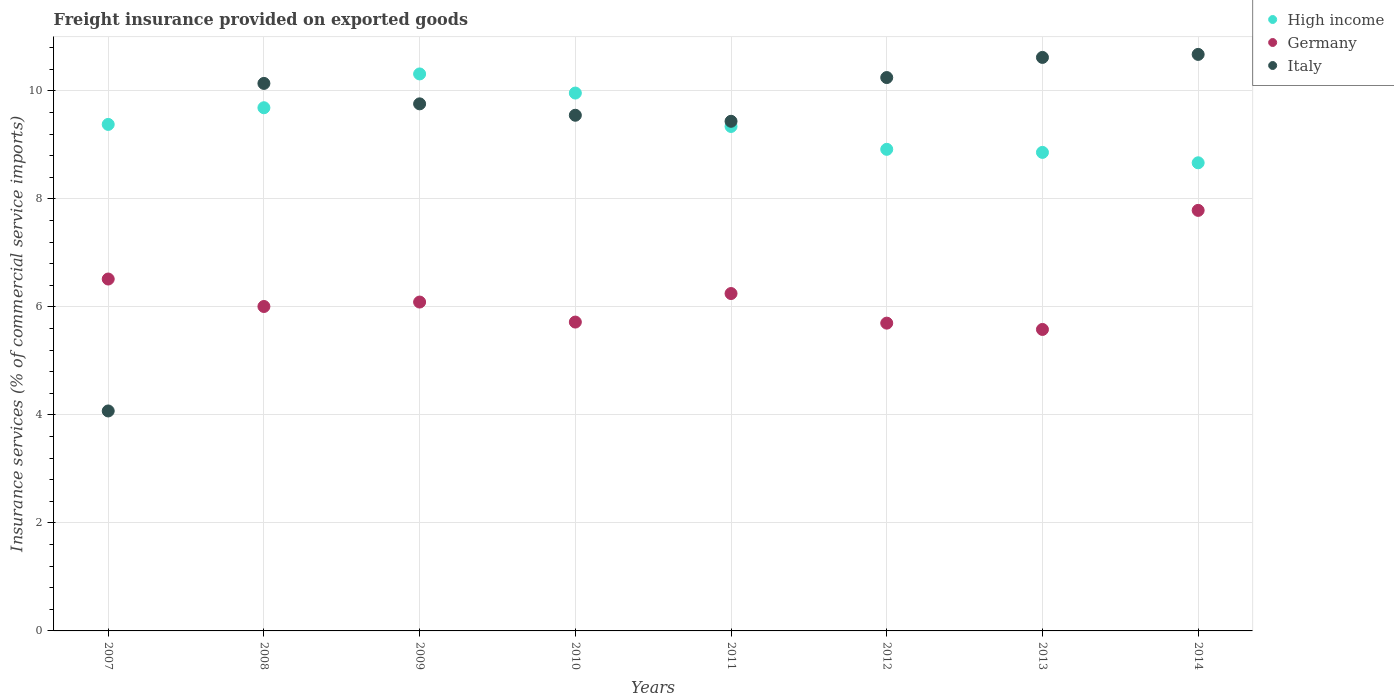How many different coloured dotlines are there?
Your answer should be compact. 3. What is the freight insurance provided on exported goods in Italy in 2007?
Ensure brevity in your answer.  4.07. Across all years, what is the maximum freight insurance provided on exported goods in Germany?
Ensure brevity in your answer.  7.79. Across all years, what is the minimum freight insurance provided on exported goods in Germany?
Your response must be concise. 5.58. What is the total freight insurance provided on exported goods in Germany in the graph?
Make the answer very short. 49.65. What is the difference between the freight insurance provided on exported goods in Italy in 2011 and that in 2014?
Ensure brevity in your answer.  -1.24. What is the difference between the freight insurance provided on exported goods in Italy in 2014 and the freight insurance provided on exported goods in Germany in 2008?
Ensure brevity in your answer.  4.67. What is the average freight insurance provided on exported goods in Italy per year?
Make the answer very short. 9.31. In the year 2007, what is the difference between the freight insurance provided on exported goods in Germany and freight insurance provided on exported goods in High income?
Offer a very short reply. -2.86. What is the ratio of the freight insurance provided on exported goods in Italy in 2011 to that in 2014?
Your response must be concise. 0.88. Is the freight insurance provided on exported goods in Germany in 2007 less than that in 2012?
Ensure brevity in your answer.  No. What is the difference between the highest and the second highest freight insurance provided on exported goods in Germany?
Give a very brief answer. 1.27. What is the difference between the highest and the lowest freight insurance provided on exported goods in Germany?
Give a very brief answer. 2.2. How many dotlines are there?
Make the answer very short. 3. How many years are there in the graph?
Keep it short and to the point. 8. What is the difference between two consecutive major ticks on the Y-axis?
Provide a short and direct response. 2. Are the values on the major ticks of Y-axis written in scientific E-notation?
Ensure brevity in your answer.  No. Does the graph contain any zero values?
Provide a short and direct response. No. What is the title of the graph?
Offer a very short reply. Freight insurance provided on exported goods. What is the label or title of the X-axis?
Your answer should be very brief. Years. What is the label or title of the Y-axis?
Give a very brief answer. Insurance services (% of commercial service imports). What is the Insurance services (% of commercial service imports) of High income in 2007?
Your response must be concise. 9.38. What is the Insurance services (% of commercial service imports) in Germany in 2007?
Provide a succinct answer. 6.52. What is the Insurance services (% of commercial service imports) in Italy in 2007?
Your answer should be compact. 4.07. What is the Insurance services (% of commercial service imports) of High income in 2008?
Ensure brevity in your answer.  9.69. What is the Insurance services (% of commercial service imports) of Germany in 2008?
Give a very brief answer. 6.01. What is the Insurance services (% of commercial service imports) of Italy in 2008?
Provide a short and direct response. 10.14. What is the Insurance services (% of commercial service imports) of High income in 2009?
Your response must be concise. 10.31. What is the Insurance services (% of commercial service imports) of Germany in 2009?
Provide a succinct answer. 6.09. What is the Insurance services (% of commercial service imports) in Italy in 2009?
Provide a short and direct response. 9.76. What is the Insurance services (% of commercial service imports) in High income in 2010?
Your response must be concise. 9.96. What is the Insurance services (% of commercial service imports) of Germany in 2010?
Provide a short and direct response. 5.72. What is the Insurance services (% of commercial service imports) in Italy in 2010?
Your answer should be compact. 9.55. What is the Insurance services (% of commercial service imports) in High income in 2011?
Offer a very short reply. 9.34. What is the Insurance services (% of commercial service imports) of Germany in 2011?
Offer a terse response. 6.25. What is the Insurance services (% of commercial service imports) in Italy in 2011?
Offer a very short reply. 9.44. What is the Insurance services (% of commercial service imports) in High income in 2012?
Offer a very short reply. 8.92. What is the Insurance services (% of commercial service imports) of Germany in 2012?
Keep it short and to the point. 5.7. What is the Insurance services (% of commercial service imports) of Italy in 2012?
Your answer should be very brief. 10.25. What is the Insurance services (% of commercial service imports) of High income in 2013?
Your answer should be very brief. 8.86. What is the Insurance services (% of commercial service imports) in Germany in 2013?
Offer a terse response. 5.58. What is the Insurance services (% of commercial service imports) in Italy in 2013?
Keep it short and to the point. 10.62. What is the Insurance services (% of commercial service imports) in High income in 2014?
Give a very brief answer. 8.67. What is the Insurance services (% of commercial service imports) of Germany in 2014?
Keep it short and to the point. 7.79. What is the Insurance services (% of commercial service imports) of Italy in 2014?
Give a very brief answer. 10.68. Across all years, what is the maximum Insurance services (% of commercial service imports) of High income?
Provide a short and direct response. 10.31. Across all years, what is the maximum Insurance services (% of commercial service imports) in Germany?
Keep it short and to the point. 7.79. Across all years, what is the maximum Insurance services (% of commercial service imports) of Italy?
Provide a short and direct response. 10.68. Across all years, what is the minimum Insurance services (% of commercial service imports) in High income?
Offer a terse response. 8.67. Across all years, what is the minimum Insurance services (% of commercial service imports) of Germany?
Make the answer very short. 5.58. Across all years, what is the minimum Insurance services (% of commercial service imports) of Italy?
Provide a short and direct response. 4.07. What is the total Insurance services (% of commercial service imports) of High income in the graph?
Provide a succinct answer. 75.13. What is the total Insurance services (% of commercial service imports) in Germany in the graph?
Your answer should be compact. 49.65. What is the total Insurance services (% of commercial service imports) in Italy in the graph?
Offer a very short reply. 74.5. What is the difference between the Insurance services (% of commercial service imports) of High income in 2007 and that in 2008?
Your answer should be compact. -0.31. What is the difference between the Insurance services (% of commercial service imports) in Germany in 2007 and that in 2008?
Your answer should be very brief. 0.51. What is the difference between the Insurance services (% of commercial service imports) in Italy in 2007 and that in 2008?
Your answer should be compact. -6.07. What is the difference between the Insurance services (% of commercial service imports) in High income in 2007 and that in 2009?
Make the answer very short. -0.93. What is the difference between the Insurance services (% of commercial service imports) of Germany in 2007 and that in 2009?
Ensure brevity in your answer.  0.43. What is the difference between the Insurance services (% of commercial service imports) of Italy in 2007 and that in 2009?
Offer a terse response. -5.69. What is the difference between the Insurance services (% of commercial service imports) in High income in 2007 and that in 2010?
Your answer should be compact. -0.58. What is the difference between the Insurance services (% of commercial service imports) in Germany in 2007 and that in 2010?
Offer a very short reply. 0.8. What is the difference between the Insurance services (% of commercial service imports) of Italy in 2007 and that in 2010?
Your answer should be compact. -5.48. What is the difference between the Insurance services (% of commercial service imports) of High income in 2007 and that in 2011?
Offer a terse response. 0.04. What is the difference between the Insurance services (% of commercial service imports) of Germany in 2007 and that in 2011?
Your response must be concise. 0.27. What is the difference between the Insurance services (% of commercial service imports) in Italy in 2007 and that in 2011?
Keep it short and to the point. -5.36. What is the difference between the Insurance services (% of commercial service imports) in High income in 2007 and that in 2012?
Offer a terse response. 0.46. What is the difference between the Insurance services (% of commercial service imports) in Germany in 2007 and that in 2012?
Give a very brief answer. 0.82. What is the difference between the Insurance services (% of commercial service imports) of Italy in 2007 and that in 2012?
Ensure brevity in your answer.  -6.17. What is the difference between the Insurance services (% of commercial service imports) of High income in 2007 and that in 2013?
Your answer should be very brief. 0.52. What is the difference between the Insurance services (% of commercial service imports) in Germany in 2007 and that in 2013?
Ensure brevity in your answer.  0.93. What is the difference between the Insurance services (% of commercial service imports) of Italy in 2007 and that in 2013?
Provide a succinct answer. -6.55. What is the difference between the Insurance services (% of commercial service imports) of High income in 2007 and that in 2014?
Ensure brevity in your answer.  0.71. What is the difference between the Insurance services (% of commercial service imports) of Germany in 2007 and that in 2014?
Give a very brief answer. -1.27. What is the difference between the Insurance services (% of commercial service imports) in Italy in 2007 and that in 2014?
Make the answer very short. -6.6. What is the difference between the Insurance services (% of commercial service imports) in High income in 2008 and that in 2009?
Offer a very short reply. -0.63. What is the difference between the Insurance services (% of commercial service imports) in Germany in 2008 and that in 2009?
Keep it short and to the point. -0.08. What is the difference between the Insurance services (% of commercial service imports) in Italy in 2008 and that in 2009?
Keep it short and to the point. 0.38. What is the difference between the Insurance services (% of commercial service imports) of High income in 2008 and that in 2010?
Ensure brevity in your answer.  -0.27. What is the difference between the Insurance services (% of commercial service imports) in Germany in 2008 and that in 2010?
Offer a very short reply. 0.29. What is the difference between the Insurance services (% of commercial service imports) in Italy in 2008 and that in 2010?
Your response must be concise. 0.59. What is the difference between the Insurance services (% of commercial service imports) in High income in 2008 and that in 2011?
Keep it short and to the point. 0.35. What is the difference between the Insurance services (% of commercial service imports) in Germany in 2008 and that in 2011?
Make the answer very short. -0.24. What is the difference between the Insurance services (% of commercial service imports) in Italy in 2008 and that in 2011?
Provide a short and direct response. 0.7. What is the difference between the Insurance services (% of commercial service imports) in High income in 2008 and that in 2012?
Your answer should be compact. 0.77. What is the difference between the Insurance services (% of commercial service imports) of Germany in 2008 and that in 2012?
Ensure brevity in your answer.  0.31. What is the difference between the Insurance services (% of commercial service imports) in Italy in 2008 and that in 2012?
Your response must be concise. -0.11. What is the difference between the Insurance services (% of commercial service imports) of High income in 2008 and that in 2013?
Provide a succinct answer. 0.83. What is the difference between the Insurance services (% of commercial service imports) of Germany in 2008 and that in 2013?
Your response must be concise. 0.43. What is the difference between the Insurance services (% of commercial service imports) in Italy in 2008 and that in 2013?
Give a very brief answer. -0.48. What is the difference between the Insurance services (% of commercial service imports) in High income in 2008 and that in 2014?
Ensure brevity in your answer.  1.02. What is the difference between the Insurance services (% of commercial service imports) in Germany in 2008 and that in 2014?
Offer a terse response. -1.78. What is the difference between the Insurance services (% of commercial service imports) of Italy in 2008 and that in 2014?
Offer a very short reply. -0.54. What is the difference between the Insurance services (% of commercial service imports) of High income in 2009 and that in 2010?
Offer a terse response. 0.35. What is the difference between the Insurance services (% of commercial service imports) of Germany in 2009 and that in 2010?
Your response must be concise. 0.37. What is the difference between the Insurance services (% of commercial service imports) of Italy in 2009 and that in 2010?
Make the answer very short. 0.21. What is the difference between the Insurance services (% of commercial service imports) of High income in 2009 and that in 2011?
Give a very brief answer. 0.97. What is the difference between the Insurance services (% of commercial service imports) of Germany in 2009 and that in 2011?
Offer a terse response. -0.16. What is the difference between the Insurance services (% of commercial service imports) of Italy in 2009 and that in 2011?
Your answer should be very brief. 0.32. What is the difference between the Insurance services (% of commercial service imports) of High income in 2009 and that in 2012?
Offer a very short reply. 1.4. What is the difference between the Insurance services (% of commercial service imports) of Germany in 2009 and that in 2012?
Your response must be concise. 0.39. What is the difference between the Insurance services (% of commercial service imports) in Italy in 2009 and that in 2012?
Provide a succinct answer. -0.49. What is the difference between the Insurance services (% of commercial service imports) of High income in 2009 and that in 2013?
Keep it short and to the point. 1.45. What is the difference between the Insurance services (% of commercial service imports) in Germany in 2009 and that in 2013?
Your answer should be compact. 0.51. What is the difference between the Insurance services (% of commercial service imports) of Italy in 2009 and that in 2013?
Offer a terse response. -0.86. What is the difference between the Insurance services (% of commercial service imports) in High income in 2009 and that in 2014?
Your answer should be compact. 1.65. What is the difference between the Insurance services (% of commercial service imports) of Germany in 2009 and that in 2014?
Keep it short and to the point. -1.7. What is the difference between the Insurance services (% of commercial service imports) in Italy in 2009 and that in 2014?
Offer a terse response. -0.92. What is the difference between the Insurance services (% of commercial service imports) in High income in 2010 and that in 2011?
Keep it short and to the point. 0.62. What is the difference between the Insurance services (% of commercial service imports) of Germany in 2010 and that in 2011?
Ensure brevity in your answer.  -0.53. What is the difference between the Insurance services (% of commercial service imports) in Italy in 2010 and that in 2011?
Ensure brevity in your answer.  0.11. What is the difference between the Insurance services (% of commercial service imports) of High income in 2010 and that in 2012?
Offer a terse response. 1.04. What is the difference between the Insurance services (% of commercial service imports) of Germany in 2010 and that in 2012?
Make the answer very short. 0.02. What is the difference between the Insurance services (% of commercial service imports) of Italy in 2010 and that in 2012?
Offer a terse response. -0.7. What is the difference between the Insurance services (% of commercial service imports) of High income in 2010 and that in 2013?
Keep it short and to the point. 1.1. What is the difference between the Insurance services (% of commercial service imports) of Germany in 2010 and that in 2013?
Your answer should be very brief. 0.14. What is the difference between the Insurance services (% of commercial service imports) in Italy in 2010 and that in 2013?
Provide a short and direct response. -1.07. What is the difference between the Insurance services (% of commercial service imports) in High income in 2010 and that in 2014?
Your response must be concise. 1.29. What is the difference between the Insurance services (% of commercial service imports) of Germany in 2010 and that in 2014?
Provide a short and direct response. -2.07. What is the difference between the Insurance services (% of commercial service imports) of Italy in 2010 and that in 2014?
Offer a terse response. -1.13. What is the difference between the Insurance services (% of commercial service imports) of High income in 2011 and that in 2012?
Keep it short and to the point. 0.42. What is the difference between the Insurance services (% of commercial service imports) in Germany in 2011 and that in 2012?
Your response must be concise. 0.55. What is the difference between the Insurance services (% of commercial service imports) in Italy in 2011 and that in 2012?
Make the answer very short. -0.81. What is the difference between the Insurance services (% of commercial service imports) in High income in 2011 and that in 2013?
Keep it short and to the point. 0.48. What is the difference between the Insurance services (% of commercial service imports) in Germany in 2011 and that in 2013?
Make the answer very short. 0.66. What is the difference between the Insurance services (% of commercial service imports) of Italy in 2011 and that in 2013?
Provide a short and direct response. -1.18. What is the difference between the Insurance services (% of commercial service imports) of High income in 2011 and that in 2014?
Provide a short and direct response. 0.67. What is the difference between the Insurance services (% of commercial service imports) of Germany in 2011 and that in 2014?
Offer a terse response. -1.54. What is the difference between the Insurance services (% of commercial service imports) in Italy in 2011 and that in 2014?
Your response must be concise. -1.24. What is the difference between the Insurance services (% of commercial service imports) in High income in 2012 and that in 2013?
Offer a very short reply. 0.06. What is the difference between the Insurance services (% of commercial service imports) in Germany in 2012 and that in 2013?
Your answer should be compact. 0.12. What is the difference between the Insurance services (% of commercial service imports) in Italy in 2012 and that in 2013?
Offer a very short reply. -0.37. What is the difference between the Insurance services (% of commercial service imports) in High income in 2012 and that in 2014?
Your answer should be very brief. 0.25. What is the difference between the Insurance services (% of commercial service imports) in Germany in 2012 and that in 2014?
Ensure brevity in your answer.  -2.09. What is the difference between the Insurance services (% of commercial service imports) of Italy in 2012 and that in 2014?
Make the answer very short. -0.43. What is the difference between the Insurance services (% of commercial service imports) in High income in 2013 and that in 2014?
Provide a succinct answer. 0.19. What is the difference between the Insurance services (% of commercial service imports) in Germany in 2013 and that in 2014?
Offer a terse response. -2.2. What is the difference between the Insurance services (% of commercial service imports) in Italy in 2013 and that in 2014?
Give a very brief answer. -0.06. What is the difference between the Insurance services (% of commercial service imports) of High income in 2007 and the Insurance services (% of commercial service imports) of Germany in 2008?
Provide a succinct answer. 3.37. What is the difference between the Insurance services (% of commercial service imports) in High income in 2007 and the Insurance services (% of commercial service imports) in Italy in 2008?
Your answer should be compact. -0.76. What is the difference between the Insurance services (% of commercial service imports) in Germany in 2007 and the Insurance services (% of commercial service imports) in Italy in 2008?
Provide a succinct answer. -3.62. What is the difference between the Insurance services (% of commercial service imports) in High income in 2007 and the Insurance services (% of commercial service imports) in Germany in 2009?
Offer a very short reply. 3.29. What is the difference between the Insurance services (% of commercial service imports) of High income in 2007 and the Insurance services (% of commercial service imports) of Italy in 2009?
Provide a short and direct response. -0.38. What is the difference between the Insurance services (% of commercial service imports) in Germany in 2007 and the Insurance services (% of commercial service imports) in Italy in 2009?
Provide a succinct answer. -3.24. What is the difference between the Insurance services (% of commercial service imports) in High income in 2007 and the Insurance services (% of commercial service imports) in Germany in 2010?
Your answer should be very brief. 3.66. What is the difference between the Insurance services (% of commercial service imports) of High income in 2007 and the Insurance services (% of commercial service imports) of Italy in 2010?
Offer a very short reply. -0.17. What is the difference between the Insurance services (% of commercial service imports) in Germany in 2007 and the Insurance services (% of commercial service imports) in Italy in 2010?
Your answer should be compact. -3.03. What is the difference between the Insurance services (% of commercial service imports) of High income in 2007 and the Insurance services (% of commercial service imports) of Germany in 2011?
Make the answer very short. 3.13. What is the difference between the Insurance services (% of commercial service imports) in High income in 2007 and the Insurance services (% of commercial service imports) in Italy in 2011?
Make the answer very short. -0.06. What is the difference between the Insurance services (% of commercial service imports) in Germany in 2007 and the Insurance services (% of commercial service imports) in Italy in 2011?
Provide a succinct answer. -2.92. What is the difference between the Insurance services (% of commercial service imports) of High income in 2007 and the Insurance services (% of commercial service imports) of Germany in 2012?
Your answer should be very brief. 3.68. What is the difference between the Insurance services (% of commercial service imports) in High income in 2007 and the Insurance services (% of commercial service imports) in Italy in 2012?
Ensure brevity in your answer.  -0.87. What is the difference between the Insurance services (% of commercial service imports) in Germany in 2007 and the Insurance services (% of commercial service imports) in Italy in 2012?
Make the answer very short. -3.73. What is the difference between the Insurance services (% of commercial service imports) in High income in 2007 and the Insurance services (% of commercial service imports) in Germany in 2013?
Provide a succinct answer. 3.8. What is the difference between the Insurance services (% of commercial service imports) of High income in 2007 and the Insurance services (% of commercial service imports) of Italy in 2013?
Offer a very short reply. -1.24. What is the difference between the Insurance services (% of commercial service imports) in Germany in 2007 and the Insurance services (% of commercial service imports) in Italy in 2013?
Your answer should be very brief. -4.1. What is the difference between the Insurance services (% of commercial service imports) in High income in 2007 and the Insurance services (% of commercial service imports) in Germany in 2014?
Offer a very short reply. 1.59. What is the difference between the Insurance services (% of commercial service imports) in High income in 2007 and the Insurance services (% of commercial service imports) in Italy in 2014?
Offer a terse response. -1.3. What is the difference between the Insurance services (% of commercial service imports) of Germany in 2007 and the Insurance services (% of commercial service imports) of Italy in 2014?
Your answer should be very brief. -4.16. What is the difference between the Insurance services (% of commercial service imports) of High income in 2008 and the Insurance services (% of commercial service imports) of Germany in 2009?
Keep it short and to the point. 3.6. What is the difference between the Insurance services (% of commercial service imports) in High income in 2008 and the Insurance services (% of commercial service imports) in Italy in 2009?
Offer a terse response. -0.07. What is the difference between the Insurance services (% of commercial service imports) in Germany in 2008 and the Insurance services (% of commercial service imports) in Italy in 2009?
Offer a very short reply. -3.75. What is the difference between the Insurance services (% of commercial service imports) of High income in 2008 and the Insurance services (% of commercial service imports) of Germany in 2010?
Your answer should be compact. 3.97. What is the difference between the Insurance services (% of commercial service imports) in High income in 2008 and the Insurance services (% of commercial service imports) in Italy in 2010?
Offer a very short reply. 0.14. What is the difference between the Insurance services (% of commercial service imports) of Germany in 2008 and the Insurance services (% of commercial service imports) of Italy in 2010?
Offer a very short reply. -3.54. What is the difference between the Insurance services (% of commercial service imports) in High income in 2008 and the Insurance services (% of commercial service imports) in Germany in 2011?
Your answer should be compact. 3.44. What is the difference between the Insurance services (% of commercial service imports) of High income in 2008 and the Insurance services (% of commercial service imports) of Italy in 2011?
Provide a short and direct response. 0.25. What is the difference between the Insurance services (% of commercial service imports) in Germany in 2008 and the Insurance services (% of commercial service imports) in Italy in 2011?
Make the answer very short. -3.43. What is the difference between the Insurance services (% of commercial service imports) in High income in 2008 and the Insurance services (% of commercial service imports) in Germany in 2012?
Offer a terse response. 3.99. What is the difference between the Insurance services (% of commercial service imports) in High income in 2008 and the Insurance services (% of commercial service imports) in Italy in 2012?
Give a very brief answer. -0.56. What is the difference between the Insurance services (% of commercial service imports) in Germany in 2008 and the Insurance services (% of commercial service imports) in Italy in 2012?
Offer a very short reply. -4.24. What is the difference between the Insurance services (% of commercial service imports) of High income in 2008 and the Insurance services (% of commercial service imports) of Germany in 2013?
Provide a succinct answer. 4.11. What is the difference between the Insurance services (% of commercial service imports) in High income in 2008 and the Insurance services (% of commercial service imports) in Italy in 2013?
Offer a terse response. -0.93. What is the difference between the Insurance services (% of commercial service imports) in Germany in 2008 and the Insurance services (% of commercial service imports) in Italy in 2013?
Your response must be concise. -4.61. What is the difference between the Insurance services (% of commercial service imports) of High income in 2008 and the Insurance services (% of commercial service imports) of Germany in 2014?
Ensure brevity in your answer.  1.9. What is the difference between the Insurance services (% of commercial service imports) in High income in 2008 and the Insurance services (% of commercial service imports) in Italy in 2014?
Provide a short and direct response. -0.99. What is the difference between the Insurance services (% of commercial service imports) of Germany in 2008 and the Insurance services (% of commercial service imports) of Italy in 2014?
Ensure brevity in your answer.  -4.67. What is the difference between the Insurance services (% of commercial service imports) in High income in 2009 and the Insurance services (% of commercial service imports) in Germany in 2010?
Your answer should be very brief. 4.59. What is the difference between the Insurance services (% of commercial service imports) in High income in 2009 and the Insurance services (% of commercial service imports) in Italy in 2010?
Provide a short and direct response. 0.77. What is the difference between the Insurance services (% of commercial service imports) in Germany in 2009 and the Insurance services (% of commercial service imports) in Italy in 2010?
Give a very brief answer. -3.46. What is the difference between the Insurance services (% of commercial service imports) in High income in 2009 and the Insurance services (% of commercial service imports) in Germany in 2011?
Ensure brevity in your answer.  4.07. What is the difference between the Insurance services (% of commercial service imports) of High income in 2009 and the Insurance services (% of commercial service imports) of Italy in 2011?
Provide a succinct answer. 0.88. What is the difference between the Insurance services (% of commercial service imports) in Germany in 2009 and the Insurance services (% of commercial service imports) in Italy in 2011?
Offer a terse response. -3.35. What is the difference between the Insurance services (% of commercial service imports) in High income in 2009 and the Insurance services (% of commercial service imports) in Germany in 2012?
Make the answer very short. 4.61. What is the difference between the Insurance services (% of commercial service imports) in High income in 2009 and the Insurance services (% of commercial service imports) in Italy in 2012?
Offer a very short reply. 0.07. What is the difference between the Insurance services (% of commercial service imports) of Germany in 2009 and the Insurance services (% of commercial service imports) of Italy in 2012?
Offer a terse response. -4.16. What is the difference between the Insurance services (% of commercial service imports) of High income in 2009 and the Insurance services (% of commercial service imports) of Germany in 2013?
Your response must be concise. 4.73. What is the difference between the Insurance services (% of commercial service imports) of High income in 2009 and the Insurance services (% of commercial service imports) of Italy in 2013?
Make the answer very short. -0.31. What is the difference between the Insurance services (% of commercial service imports) of Germany in 2009 and the Insurance services (% of commercial service imports) of Italy in 2013?
Offer a very short reply. -4.53. What is the difference between the Insurance services (% of commercial service imports) in High income in 2009 and the Insurance services (% of commercial service imports) in Germany in 2014?
Your answer should be very brief. 2.53. What is the difference between the Insurance services (% of commercial service imports) in High income in 2009 and the Insurance services (% of commercial service imports) in Italy in 2014?
Your response must be concise. -0.36. What is the difference between the Insurance services (% of commercial service imports) in Germany in 2009 and the Insurance services (% of commercial service imports) in Italy in 2014?
Your answer should be compact. -4.59. What is the difference between the Insurance services (% of commercial service imports) in High income in 2010 and the Insurance services (% of commercial service imports) in Germany in 2011?
Offer a terse response. 3.71. What is the difference between the Insurance services (% of commercial service imports) of High income in 2010 and the Insurance services (% of commercial service imports) of Italy in 2011?
Your answer should be very brief. 0.52. What is the difference between the Insurance services (% of commercial service imports) in Germany in 2010 and the Insurance services (% of commercial service imports) in Italy in 2011?
Your answer should be very brief. -3.72. What is the difference between the Insurance services (% of commercial service imports) of High income in 2010 and the Insurance services (% of commercial service imports) of Germany in 2012?
Your answer should be very brief. 4.26. What is the difference between the Insurance services (% of commercial service imports) of High income in 2010 and the Insurance services (% of commercial service imports) of Italy in 2012?
Provide a succinct answer. -0.29. What is the difference between the Insurance services (% of commercial service imports) in Germany in 2010 and the Insurance services (% of commercial service imports) in Italy in 2012?
Your answer should be compact. -4.53. What is the difference between the Insurance services (% of commercial service imports) in High income in 2010 and the Insurance services (% of commercial service imports) in Germany in 2013?
Your response must be concise. 4.38. What is the difference between the Insurance services (% of commercial service imports) of High income in 2010 and the Insurance services (% of commercial service imports) of Italy in 2013?
Provide a short and direct response. -0.66. What is the difference between the Insurance services (% of commercial service imports) of Germany in 2010 and the Insurance services (% of commercial service imports) of Italy in 2013?
Ensure brevity in your answer.  -4.9. What is the difference between the Insurance services (% of commercial service imports) of High income in 2010 and the Insurance services (% of commercial service imports) of Germany in 2014?
Provide a short and direct response. 2.17. What is the difference between the Insurance services (% of commercial service imports) in High income in 2010 and the Insurance services (% of commercial service imports) in Italy in 2014?
Your answer should be compact. -0.72. What is the difference between the Insurance services (% of commercial service imports) in Germany in 2010 and the Insurance services (% of commercial service imports) in Italy in 2014?
Your response must be concise. -4.96. What is the difference between the Insurance services (% of commercial service imports) in High income in 2011 and the Insurance services (% of commercial service imports) in Germany in 2012?
Keep it short and to the point. 3.64. What is the difference between the Insurance services (% of commercial service imports) of High income in 2011 and the Insurance services (% of commercial service imports) of Italy in 2012?
Your answer should be compact. -0.91. What is the difference between the Insurance services (% of commercial service imports) of Germany in 2011 and the Insurance services (% of commercial service imports) of Italy in 2012?
Keep it short and to the point. -4. What is the difference between the Insurance services (% of commercial service imports) of High income in 2011 and the Insurance services (% of commercial service imports) of Germany in 2013?
Offer a terse response. 3.76. What is the difference between the Insurance services (% of commercial service imports) of High income in 2011 and the Insurance services (% of commercial service imports) of Italy in 2013?
Provide a short and direct response. -1.28. What is the difference between the Insurance services (% of commercial service imports) in Germany in 2011 and the Insurance services (% of commercial service imports) in Italy in 2013?
Your answer should be compact. -4.37. What is the difference between the Insurance services (% of commercial service imports) in High income in 2011 and the Insurance services (% of commercial service imports) in Germany in 2014?
Your response must be concise. 1.55. What is the difference between the Insurance services (% of commercial service imports) of High income in 2011 and the Insurance services (% of commercial service imports) of Italy in 2014?
Provide a short and direct response. -1.33. What is the difference between the Insurance services (% of commercial service imports) of Germany in 2011 and the Insurance services (% of commercial service imports) of Italy in 2014?
Ensure brevity in your answer.  -4.43. What is the difference between the Insurance services (% of commercial service imports) of High income in 2012 and the Insurance services (% of commercial service imports) of Germany in 2013?
Provide a succinct answer. 3.34. What is the difference between the Insurance services (% of commercial service imports) in High income in 2012 and the Insurance services (% of commercial service imports) in Italy in 2013?
Offer a terse response. -1.7. What is the difference between the Insurance services (% of commercial service imports) of Germany in 2012 and the Insurance services (% of commercial service imports) of Italy in 2013?
Your response must be concise. -4.92. What is the difference between the Insurance services (% of commercial service imports) of High income in 2012 and the Insurance services (% of commercial service imports) of Germany in 2014?
Your answer should be compact. 1.13. What is the difference between the Insurance services (% of commercial service imports) in High income in 2012 and the Insurance services (% of commercial service imports) in Italy in 2014?
Your answer should be compact. -1.76. What is the difference between the Insurance services (% of commercial service imports) in Germany in 2012 and the Insurance services (% of commercial service imports) in Italy in 2014?
Provide a succinct answer. -4.98. What is the difference between the Insurance services (% of commercial service imports) of High income in 2013 and the Insurance services (% of commercial service imports) of Germany in 2014?
Offer a very short reply. 1.07. What is the difference between the Insurance services (% of commercial service imports) in High income in 2013 and the Insurance services (% of commercial service imports) in Italy in 2014?
Provide a short and direct response. -1.81. What is the difference between the Insurance services (% of commercial service imports) of Germany in 2013 and the Insurance services (% of commercial service imports) of Italy in 2014?
Offer a terse response. -5.09. What is the average Insurance services (% of commercial service imports) in High income per year?
Your answer should be very brief. 9.39. What is the average Insurance services (% of commercial service imports) in Germany per year?
Keep it short and to the point. 6.21. What is the average Insurance services (% of commercial service imports) of Italy per year?
Offer a terse response. 9.31. In the year 2007, what is the difference between the Insurance services (% of commercial service imports) in High income and Insurance services (% of commercial service imports) in Germany?
Ensure brevity in your answer.  2.86. In the year 2007, what is the difference between the Insurance services (% of commercial service imports) of High income and Insurance services (% of commercial service imports) of Italy?
Give a very brief answer. 5.31. In the year 2007, what is the difference between the Insurance services (% of commercial service imports) of Germany and Insurance services (% of commercial service imports) of Italy?
Your answer should be very brief. 2.44. In the year 2008, what is the difference between the Insurance services (% of commercial service imports) in High income and Insurance services (% of commercial service imports) in Germany?
Make the answer very short. 3.68. In the year 2008, what is the difference between the Insurance services (% of commercial service imports) of High income and Insurance services (% of commercial service imports) of Italy?
Offer a terse response. -0.45. In the year 2008, what is the difference between the Insurance services (% of commercial service imports) in Germany and Insurance services (% of commercial service imports) in Italy?
Your answer should be compact. -4.13. In the year 2009, what is the difference between the Insurance services (% of commercial service imports) in High income and Insurance services (% of commercial service imports) in Germany?
Ensure brevity in your answer.  4.22. In the year 2009, what is the difference between the Insurance services (% of commercial service imports) in High income and Insurance services (% of commercial service imports) in Italy?
Your answer should be compact. 0.55. In the year 2009, what is the difference between the Insurance services (% of commercial service imports) of Germany and Insurance services (% of commercial service imports) of Italy?
Provide a short and direct response. -3.67. In the year 2010, what is the difference between the Insurance services (% of commercial service imports) in High income and Insurance services (% of commercial service imports) in Germany?
Ensure brevity in your answer.  4.24. In the year 2010, what is the difference between the Insurance services (% of commercial service imports) of High income and Insurance services (% of commercial service imports) of Italy?
Offer a terse response. 0.41. In the year 2010, what is the difference between the Insurance services (% of commercial service imports) of Germany and Insurance services (% of commercial service imports) of Italy?
Your answer should be compact. -3.83. In the year 2011, what is the difference between the Insurance services (% of commercial service imports) of High income and Insurance services (% of commercial service imports) of Germany?
Keep it short and to the point. 3.09. In the year 2011, what is the difference between the Insurance services (% of commercial service imports) of High income and Insurance services (% of commercial service imports) of Italy?
Give a very brief answer. -0.1. In the year 2011, what is the difference between the Insurance services (% of commercial service imports) in Germany and Insurance services (% of commercial service imports) in Italy?
Provide a short and direct response. -3.19. In the year 2012, what is the difference between the Insurance services (% of commercial service imports) of High income and Insurance services (% of commercial service imports) of Germany?
Provide a short and direct response. 3.22. In the year 2012, what is the difference between the Insurance services (% of commercial service imports) of High income and Insurance services (% of commercial service imports) of Italy?
Offer a terse response. -1.33. In the year 2012, what is the difference between the Insurance services (% of commercial service imports) of Germany and Insurance services (% of commercial service imports) of Italy?
Your response must be concise. -4.55. In the year 2013, what is the difference between the Insurance services (% of commercial service imports) of High income and Insurance services (% of commercial service imports) of Germany?
Make the answer very short. 3.28. In the year 2013, what is the difference between the Insurance services (% of commercial service imports) of High income and Insurance services (% of commercial service imports) of Italy?
Give a very brief answer. -1.76. In the year 2013, what is the difference between the Insurance services (% of commercial service imports) of Germany and Insurance services (% of commercial service imports) of Italy?
Give a very brief answer. -5.04. In the year 2014, what is the difference between the Insurance services (% of commercial service imports) of High income and Insurance services (% of commercial service imports) of Germany?
Ensure brevity in your answer.  0.88. In the year 2014, what is the difference between the Insurance services (% of commercial service imports) of High income and Insurance services (% of commercial service imports) of Italy?
Make the answer very short. -2.01. In the year 2014, what is the difference between the Insurance services (% of commercial service imports) in Germany and Insurance services (% of commercial service imports) in Italy?
Give a very brief answer. -2.89. What is the ratio of the Insurance services (% of commercial service imports) in High income in 2007 to that in 2008?
Your answer should be compact. 0.97. What is the ratio of the Insurance services (% of commercial service imports) of Germany in 2007 to that in 2008?
Ensure brevity in your answer.  1.08. What is the ratio of the Insurance services (% of commercial service imports) of Italy in 2007 to that in 2008?
Keep it short and to the point. 0.4. What is the ratio of the Insurance services (% of commercial service imports) in High income in 2007 to that in 2009?
Make the answer very short. 0.91. What is the ratio of the Insurance services (% of commercial service imports) of Germany in 2007 to that in 2009?
Give a very brief answer. 1.07. What is the ratio of the Insurance services (% of commercial service imports) of Italy in 2007 to that in 2009?
Give a very brief answer. 0.42. What is the ratio of the Insurance services (% of commercial service imports) in High income in 2007 to that in 2010?
Provide a succinct answer. 0.94. What is the ratio of the Insurance services (% of commercial service imports) of Germany in 2007 to that in 2010?
Your answer should be very brief. 1.14. What is the ratio of the Insurance services (% of commercial service imports) in Italy in 2007 to that in 2010?
Provide a short and direct response. 0.43. What is the ratio of the Insurance services (% of commercial service imports) in High income in 2007 to that in 2011?
Offer a terse response. 1. What is the ratio of the Insurance services (% of commercial service imports) of Germany in 2007 to that in 2011?
Keep it short and to the point. 1.04. What is the ratio of the Insurance services (% of commercial service imports) of Italy in 2007 to that in 2011?
Your answer should be very brief. 0.43. What is the ratio of the Insurance services (% of commercial service imports) of High income in 2007 to that in 2012?
Offer a terse response. 1.05. What is the ratio of the Insurance services (% of commercial service imports) of Germany in 2007 to that in 2012?
Your answer should be compact. 1.14. What is the ratio of the Insurance services (% of commercial service imports) of Italy in 2007 to that in 2012?
Give a very brief answer. 0.4. What is the ratio of the Insurance services (% of commercial service imports) in High income in 2007 to that in 2013?
Provide a succinct answer. 1.06. What is the ratio of the Insurance services (% of commercial service imports) of Germany in 2007 to that in 2013?
Give a very brief answer. 1.17. What is the ratio of the Insurance services (% of commercial service imports) in Italy in 2007 to that in 2013?
Provide a succinct answer. 0.38. What is the ratio of the Insurance services (% of commercial service imports) of High income in 2007 to that in 2014?
Provide a succinct answer. 1.08. What is the ratio of the Insurance services (% of commercial service imports) in Germany in 2007 to that in 2014?
Make the answer very short. 0.84. What is the ratio of the Insurance services (% of commercial service imports) in Italy in 2007 to that in 2014?
Your response must be concise. 0.38. What is the ratio of the Insurance services (% of commercial service imports) of High income in 2008 to that in 2009?
Provide a short and direct response. 0.94. What is the ratio of the Insurance services (% of commercial service imports) of Germany in 2008 to that in 2009?
Ensure brevity in your answer.  0.99. What is the ratio of the Insurance services (% of commercial service imports) in Italy in 2008 to that in 2009?
Provide a short and direct response. 1.04. What is the ratio of the Insurance services (% of commercial service imports) in High income in 2008 to that in 2010?
Make the answer very short. 0.97. What is the ratio of the Insurance services (% of commercial service imports) of Germany in 2008 to that in 2010?
Give a very brief answer. 1.05. What is the ratio of the Insurance services (% of commercial service imports) of Italy in 2008 to that in 2010?
Keep it short and to the point. 1.06. What is the ratio of the Insurance services (% of commercial service imports) of High income in 2008 to that in 2011?
Ensure brevity in your answer.  1.04. What is the ratio of the Insurance services (% of commercial service imports) of Germany in 2008 to that in 2011?
Ensure brevity in your answer.  0.96. What is the ratio of the Insurance services (% of commercial service imports) of Italy in 2008 to that in 2011?
Ensure brevity in your answer.  1.07. What is the ratio of the Insurance services (% of commercial service imports) in High income in 2008 to that in 2012?
Your answer should be compact. 1.09. What is the ratio of the Insurance services (% of commercial service imports) in Germany in 2008 to that in 2012?
Keep it short and to the point. 1.05. What is the ratio of the Insurance services (% of commercial service imports) in High income in 2008 to that in 2013?
Ensure brevity in your answer.  1.09. What is the ratio of the Insurance services (% of commercial service imports) of Germany in 2008 to that in 2013?
Keep it short and to the point. 1.08. What is the ratio of the Insurance services (% of commercial service imports) in Italy in 2008 to that in 2013?
Offer a very short reply. 0.95. What is the ratio of the Insurance services (% of commercial service imports) of High income in 2008 to that in 2014?
Provide a short and direct response. 1.12. What is the ratio of the Insurance services (% of commercial service imports) in Germany in 2008 to that in 2014?
Provide a short and direct response. 0.77. What is the ratio of the Insurance services (% of commercial service imports) of Italy in 2008 to that in 2014?
Ensure brevity in your answer.  0.95. What is the ratio of the Insurance services (% of commercial service imports) of High income in 2009 to that in 2010?
Offer a terse response. 1.04. What is the ratio of the Insurance services (% of commercial service imports) of Germany in 2009 to that in 2010?
Offer a terse response. 1.06. What is the ratio of the Insurance services (% of commercial service imports) in Italy in 2009 to that in 2010?
Give a very brief answer. 1.02. What is the ratio of the Insurance services (% of commercial service imports) of High income in 2009 to that in 2011?
Make the answer very short. 1.1. What is the ratio of the Insurance services (% of commercial service imports) in Germany in 2009 to that in 2011?
Offer a very short reply. 0.97. What is the ratio of the Insurance services (% of commercial service imports) of Italy in 2009 to that in 2011?
Your response must be concise. 1.03. What is the ratio of the Insurance services (% of commercial service imports) in High income in 2009 to that in 2012?
Ensure brevity in your answer.  1.16. What is the ratio of the Insurance services (% of commercial service imports) in Germany in 2009 to that in 2012?
Offer a very short reply. 1.07. What is the ratio of the Insurance services (% of commercial service imports) of Italy in 2009 to that in 2012?
Your answer should be compact. 0.95. What is the ratio of the Insurance services (% of commercial service imports) in High income in 2009 to that in 2013?
Give a very brief answer. 1.16. What is the ratio of the Insurance services (% of commercial service imports) of Germany in 2009 to that in 2013?
Your response must be concise. 1.09. What is the ratio of the Insurance services (% of commercial service imports) of Italy in 2009 to that in 2013?
Provide a short and direct response. 0.92. What is the ratio of the Insurance services (% of commercial service imports) of High income in 2009 to that in 2014?
Give a very brief answer. 1.19. What is the ratio of the Insurance services (% of commercial service imports) in Germany in 2009 to that in 2014?
Offer a very short reply. 0.78. What is the ratio of the Insurance services (% of commercial service imports) in Italy in 2009 to that in 2014?
Make the answer very short. 0.91. What is the ratio of the Insurance services (% of commercial service imports) in High income in 2010 to that in 2011?
Your answer should be compact. 1.07. What is the ratio of the Insurance services (% of commercial service imports) in Germany in 2010 to that in 2011?
Make the answer very short. 0.92. What is the ratio of the Insurance services (% of commercial service imports) of Italy in 2010 to that in 2011?
Make the answer very short. 1.01. What is the ratio of the Insurance services (% of commercial service imports) in High income in 2010 to that in 2012?
Your answer should be very brief. 1.12. What is the ratio of the Insurance services (% of commercial service imports) of Germany in 2010 to that in 2012?
Offer a very short reply. 1. What is the ratio of the Insurance services (% of commercial service imports) of Italy in 2010 to that in 2012?
Offer a very short reply. 0.93. What is the ratio of the Insurance services (% of commercial service imports) of High income in 2010 to that in 2013?
Keep it short and to the point. 1.12. What is the ratio of the Insurance services (% of commercial service imports) in Germany in 2010 to that in 2013?
Make the answer very short. 1.02. What is the ratio of the Insurance services (% of commercial service imports) in Italy in 2010 to that in 2013?
Provide a short and direct response. 0.9. What is the ratio of the Insurance services (% of commercial service imports) in High income in 2010 to that in 2014?
Give a very brief answer. 1.15. What is the ratio of the Insurance services (% of commercial service imports) in Germany in 2010 to that in 2014?
Provide a succinct answer. 0.73. What is the ratio of the Insurance services (% of commercial service imports) of Italy in 2010 to that in 2014?
Provide a short and direct response. 0.89. What is the ratio of the Insurance services (% of commercial service imports) of High income in 2011 to that in 2012?
Provide a succinct answer. 1.05. What is the ratio of the Insurance services (% of commercial service imports) of Germany in 2011 to that in 2012?
Provide a short and direct response. 1.1. What is the ratio of the Insurance services (% of commercial service imports) in Italy in 2011 to that in 2012?
Your response must be concise. 0.92. What is the ratio of the Insurance services (% of commercial service imports) of High income in 2011 to that in 2013?
Your answer should be compact. 1.05. What is the ratio of the Insurance services (% of commercial service imports) of Germany in 2011 to that in 2013?
Your answer should be compact. 1.12. What is the ratio of the Insurance services (% of commercial service imports) in Italy in 2011 to that in 2013?
Provide a succinct answer. 0.89. What is the ratio of the Insurance services (% of commercial service imports) in High income in 2011 to that in 2014?
Make the answer very short. 1.08. What is the ratio of the Insurance services (% of commercial service imports) in Germany in 2011 to that in 2014?
Provide a succinct answer. 0.8. What is the ratio of the Insurance services (% of commercial service imports) in Italy in 2011 to that in 2014?
Provide a short and direct response. 0.88. What is the ratio of the Insurance services (% of commercial service imports) of High income in 2012 to that in 2013?
Give a very brief answer. 1.01. What is the ratio of the Insurance services (% of commercial service imports) of Germany in 2012 to that in 2013?
Give a very brief answer. 1.02. What is the ratio of the Insurance services (% of commercial service imports) of Italy in 2012 to that in 2013?
Offer a terse response. 0.96. What is the ratio of the Insurance services (% of commercial service imports) of High income in 2012 to that in 2014?
Provide a succinct answer. 1.03. What is the ratio of the Insurance services (% of commercial service imports) of Germany in 2012 to that in 2014?
Your response must be concise. 0.73. What is the ratio of the Insurance services (% of commercial service imports) of Italy in 2012 to that in 2014?
Ensure brevity in your answer.  0.96. What is the ratio of the Insurance services (% of commercial service imports) in High income in 2013 to that in 2014?
Give a very brief answer. 1.02. What is the ratio of the Insurance services (% of commercial service imports) of Germany in 2013 to that in 2014?
Offer a very short reply. 0.72. What is the ratio of the Insurance services (% of commercial service imports) of Italy in 2013 to that in 2014?
Provide a short and direct response. 0.99. What is the difference between the highest and the second highest Insurance services (% of commercial service imports) in High income?
Offer a very short reply. 0.35. What is the difference between the highest and the second highest Insurance services (% of commercial service imports) of Germany?
Your answer should be compact. 1.27. What is the difference between the highest and the second highest Insurance services (% of commercial service imports) of Italy?
Ensure brevity in your answer.  0.06. What is the difference between the highest and the lowest Insurance services (% of commercial service imports) in High income?
Provide a succinct answer. 1.65. What is the difference between the highest and the lowest Insurance services (% of commercial service imports) of Germany?
Your answer should be very brief. 2.2. What is the difference between the highest and the lowest Insurance services (% of commercial service imports) in Italy?
Make the answer very short. 6.6. 